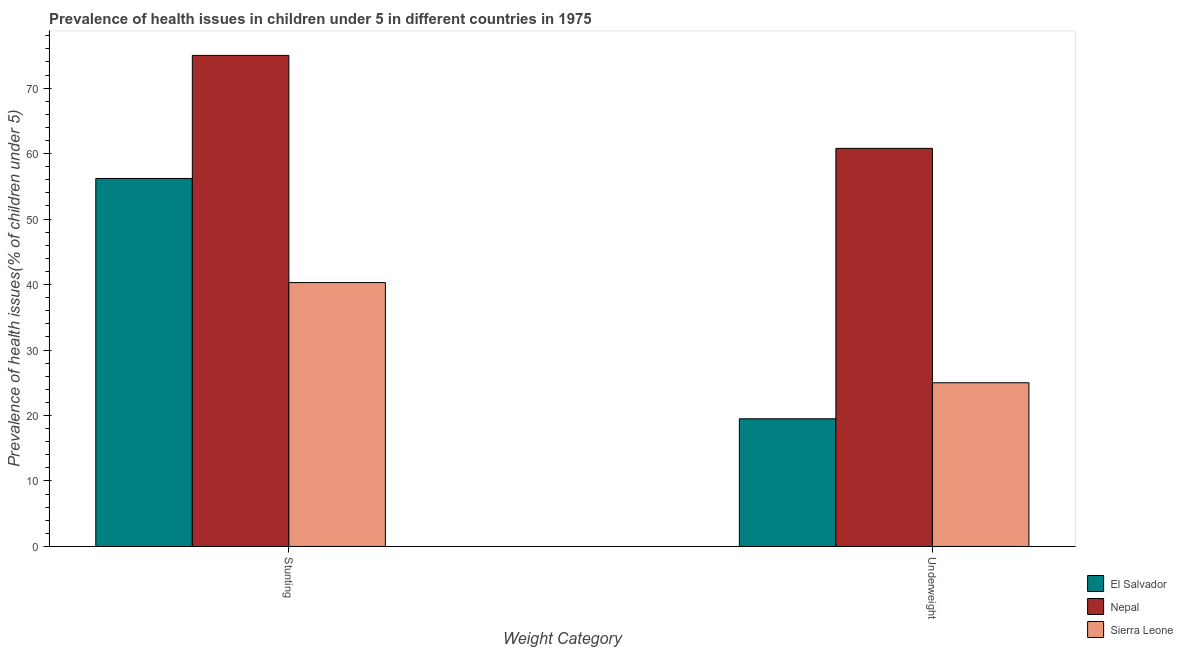What is the label of the 1st group of bars from the left?
Your response must be concise. Stunting. Across all countries, what is the maximum percentage of underweight children?
Offer a terse response. 60.8. In which country was the percentage of underweight children maximum?
Provide a succinct answer. Nepal. In which country was the percentage of underweight children minimum?
Provide a short and direct response. El Salvador. What is the total percentage of stunted children in the graph?
Give a very brief answer. 171.5. What is the difference between the percentage of underweight children in Nepal and that in Sierra Leone?
Offer a very short reply. 35.8. What is the difference between the percentage of underweight children in El Salvador and the percentage of stunted children in Nepal?
Keep it short and to the point. -55.5. What is the average percentage of stunted children per country?
Offer a terse response. 57.17. What is the difference between the percentage of underweight children and percentage of stunted children in Nepal?
Your answer should be compact. -14.2. What is the ratio of the percentage of underweight children in El Salvador to that in Sierra Leone?
Offer a very short reply. 0.78. What does the 2nd bar from the left in Underweight represents?
Offer a very short reply. Nepal. What does the 3rd bar from the right in Underweight represents?
Your answer should be compact. El Salvador. How many bars are there?
Your response must be concise. 6. Are all the bars in the graph horizontal?
Provide a short and direct response. No. How many countries are there in the graph?
Offer a very short reply. 3. What is the title of the graph?
Provide a succinct answer. Prevalence of health issues in children under 5 in different countries in 1975. What is the label or title of the X-axis?
Keep it short and to the point. Weight Category. What is the label or title of the Y-axis?
Your response must be concise. Prevalence of health issues(% of children under 5). What is the Prevalence of health issues(% of children under 5) of El Salvador in Stunting?
Your answer should be very brief. 56.2. What is the Prevalence of health issues(% of children under 5) of Nepal in Stunting?
Offer a terse response. 75. What is the Prevalence of health issues(% of children under 5) of Sierra Leone in Stunting?
Make the answer very short. 40.3. What is the Prevalence of health issues(% of children under 5) of Nepal in Underweight?
Your answer should be compact. 60.8. What is the Prevalence of health issues(% of children under 5) of Sierra Leone in Underweight?
Offer a very short reply. 25. Across all Weight Category, what is the maximum Prevalence of health issues(% of children under 5) in El Salvador?
Keep it short and to the point. 56.2. Across all Weight Category, what is the maximum Prevalence of health issues(% of children under 5) in Nepal?
Offer a very short reply. 75. Across all Weight Category, what is the maximum Prevalence of health issues(% of children under 5) in Sierra Leone?
Provide a succinct answer. 40.3. Across all Weight Category, what is the minimum Prevalence of health issues(% of children under 5) in Nepal?
Offer a very short reply. 60.8. Across all Weight Category, what is the minimum Prevalence of health issues(% of children under 5) of Sierra Leone?
Keep it short and to the point. 25. What is the total Prevalence of health issues(% of children under 5) of El Salvador in the graph?
Provide a short and direct response. 75.7. What is the total Prevalence of health issues(% of children under 5) in Nepal in the graph?
Keep it short and to the point. 135.8. What is the total Prevalence of health issues(% of children under 5) of Sierra Leone in the graph?
Provide a short and direct response. 65.3. What is the difference between the Prevalence of health issues(% of children under 5) of El Salvador in Stunting and that in Underweight?
Offer a very short reply. 36.7. What is the difference between the Prevalence of health issues(% of children under 5) of Sierra Leone in Stunting and that in Underweight?
Provide a short and direct response. 15.3. What is the difference between the Prevalence of health issues(% of children under 5) of El Salvador in Stunting and the Prevalence of health issues(% of children under 5) of Nepal in Underweight?
Provide a succinct answer. -4.6. What is the difference between the Prevalence of health issues(% of children under 5) in El Salvador in Stunting and the Prevalence of health issues(% of children under 5) in Sierra Leone in Underweight?
Your response must be concise. 31.2. What is the average Prevalence of health issues(% of children under 5) in El Salvador per Weight Category?
Your answer should be compact. 37.85. What is the average Prevalence of health issues(% of children under 5) of Nepal per Weight Category?
Make the answer very short. 67.9. What is the average Prevalence of health issues(% of children under 5) of Sierra Leone per Weight Category?
Provide a short and direct response. 32.65. What is the difference between the Prevalence of health issues(% of children under 5) of El Salvador and Prevalence of health issues(% of children under 5) of Nepal in Stunting?
Give a very brief answer. -18.8. What is the difference between the Prevalence of health issues(% of children under 5) of El Salvador and Prevalence of health issues(% of children under 5) of Sierra Leone in Stunting?
Keep it short and to the point. 15.9. What is the difference between the Prevalence of health issues(% of children under 5) in Nepal and Prevalence of health issues(% of children under 5) in Sierra Leone in Stunting?
Make the answer very short. 34.7. What is the difference between the Prevalence of health issues(% of children under 5) in El Salvador and Prevalence of health issues(% of children under 5) in Nepal in Underweight?
Keep it short and to the point. -41.3. What is the difference between the Prevalence of health issues(% of children under 5) in Nepal and Prevalence of health issues(% of children under 5) in Sierra Leone in Underweight?
Give a very brief answer. 35.8. What is the ratio of the Prevalence of health issues(% of children under 5) of El Salvador in Stunting to that in Underweight?
Your answer should be very brief. 2.88. What is the ratio of the Prevalence of health issues(% of children under 5) of Nepal in Stunting to that in Underweight?
Your answer should be very brief. 1.23. What is the ratio of the Prevalence of health issues(% of children under 5) in Sierra Leone in Stunting to that in Underweight?
Offer a terse response. 1.61. What is the difference between the highest and the second highest Prevalence of health issues(% of children under 5) of El Salvador?
Offer a very short reply. 36.7. What is the difference between the highest and the second highest Prevalence of health issues(% of children under 5) in Sierra Leone?
Your response must be concise. 15.3. What is the difference between the highest and the lowest Prevalence of health issues(% of children under 5) in El Salvador?
Your answer should be compact. 36.7. 